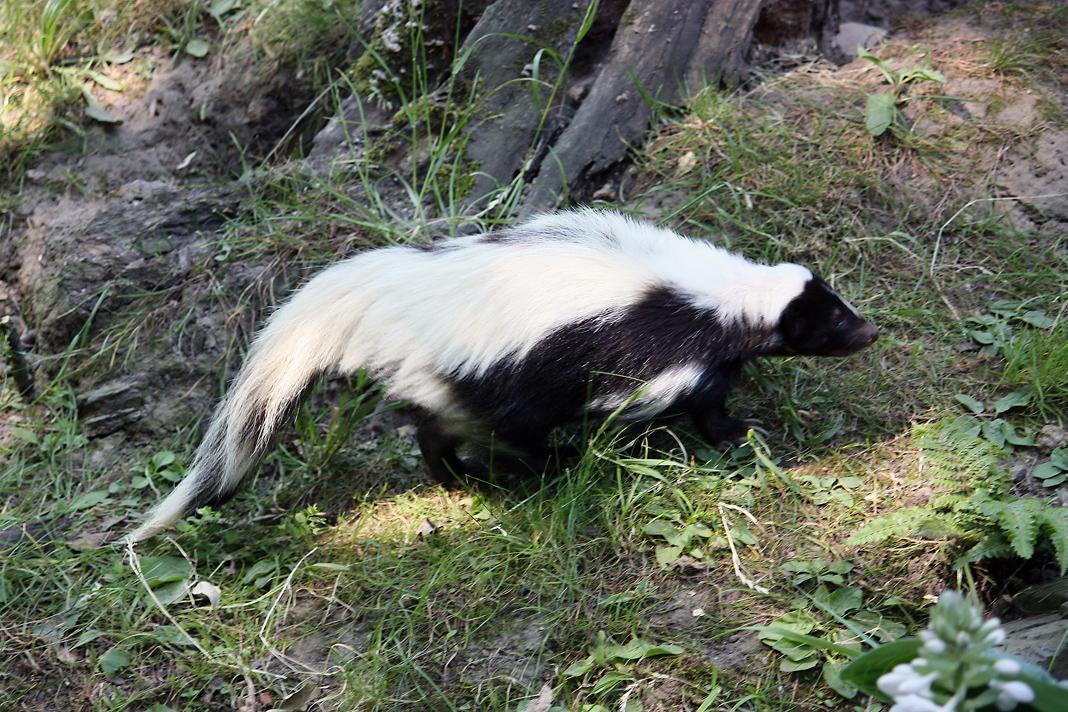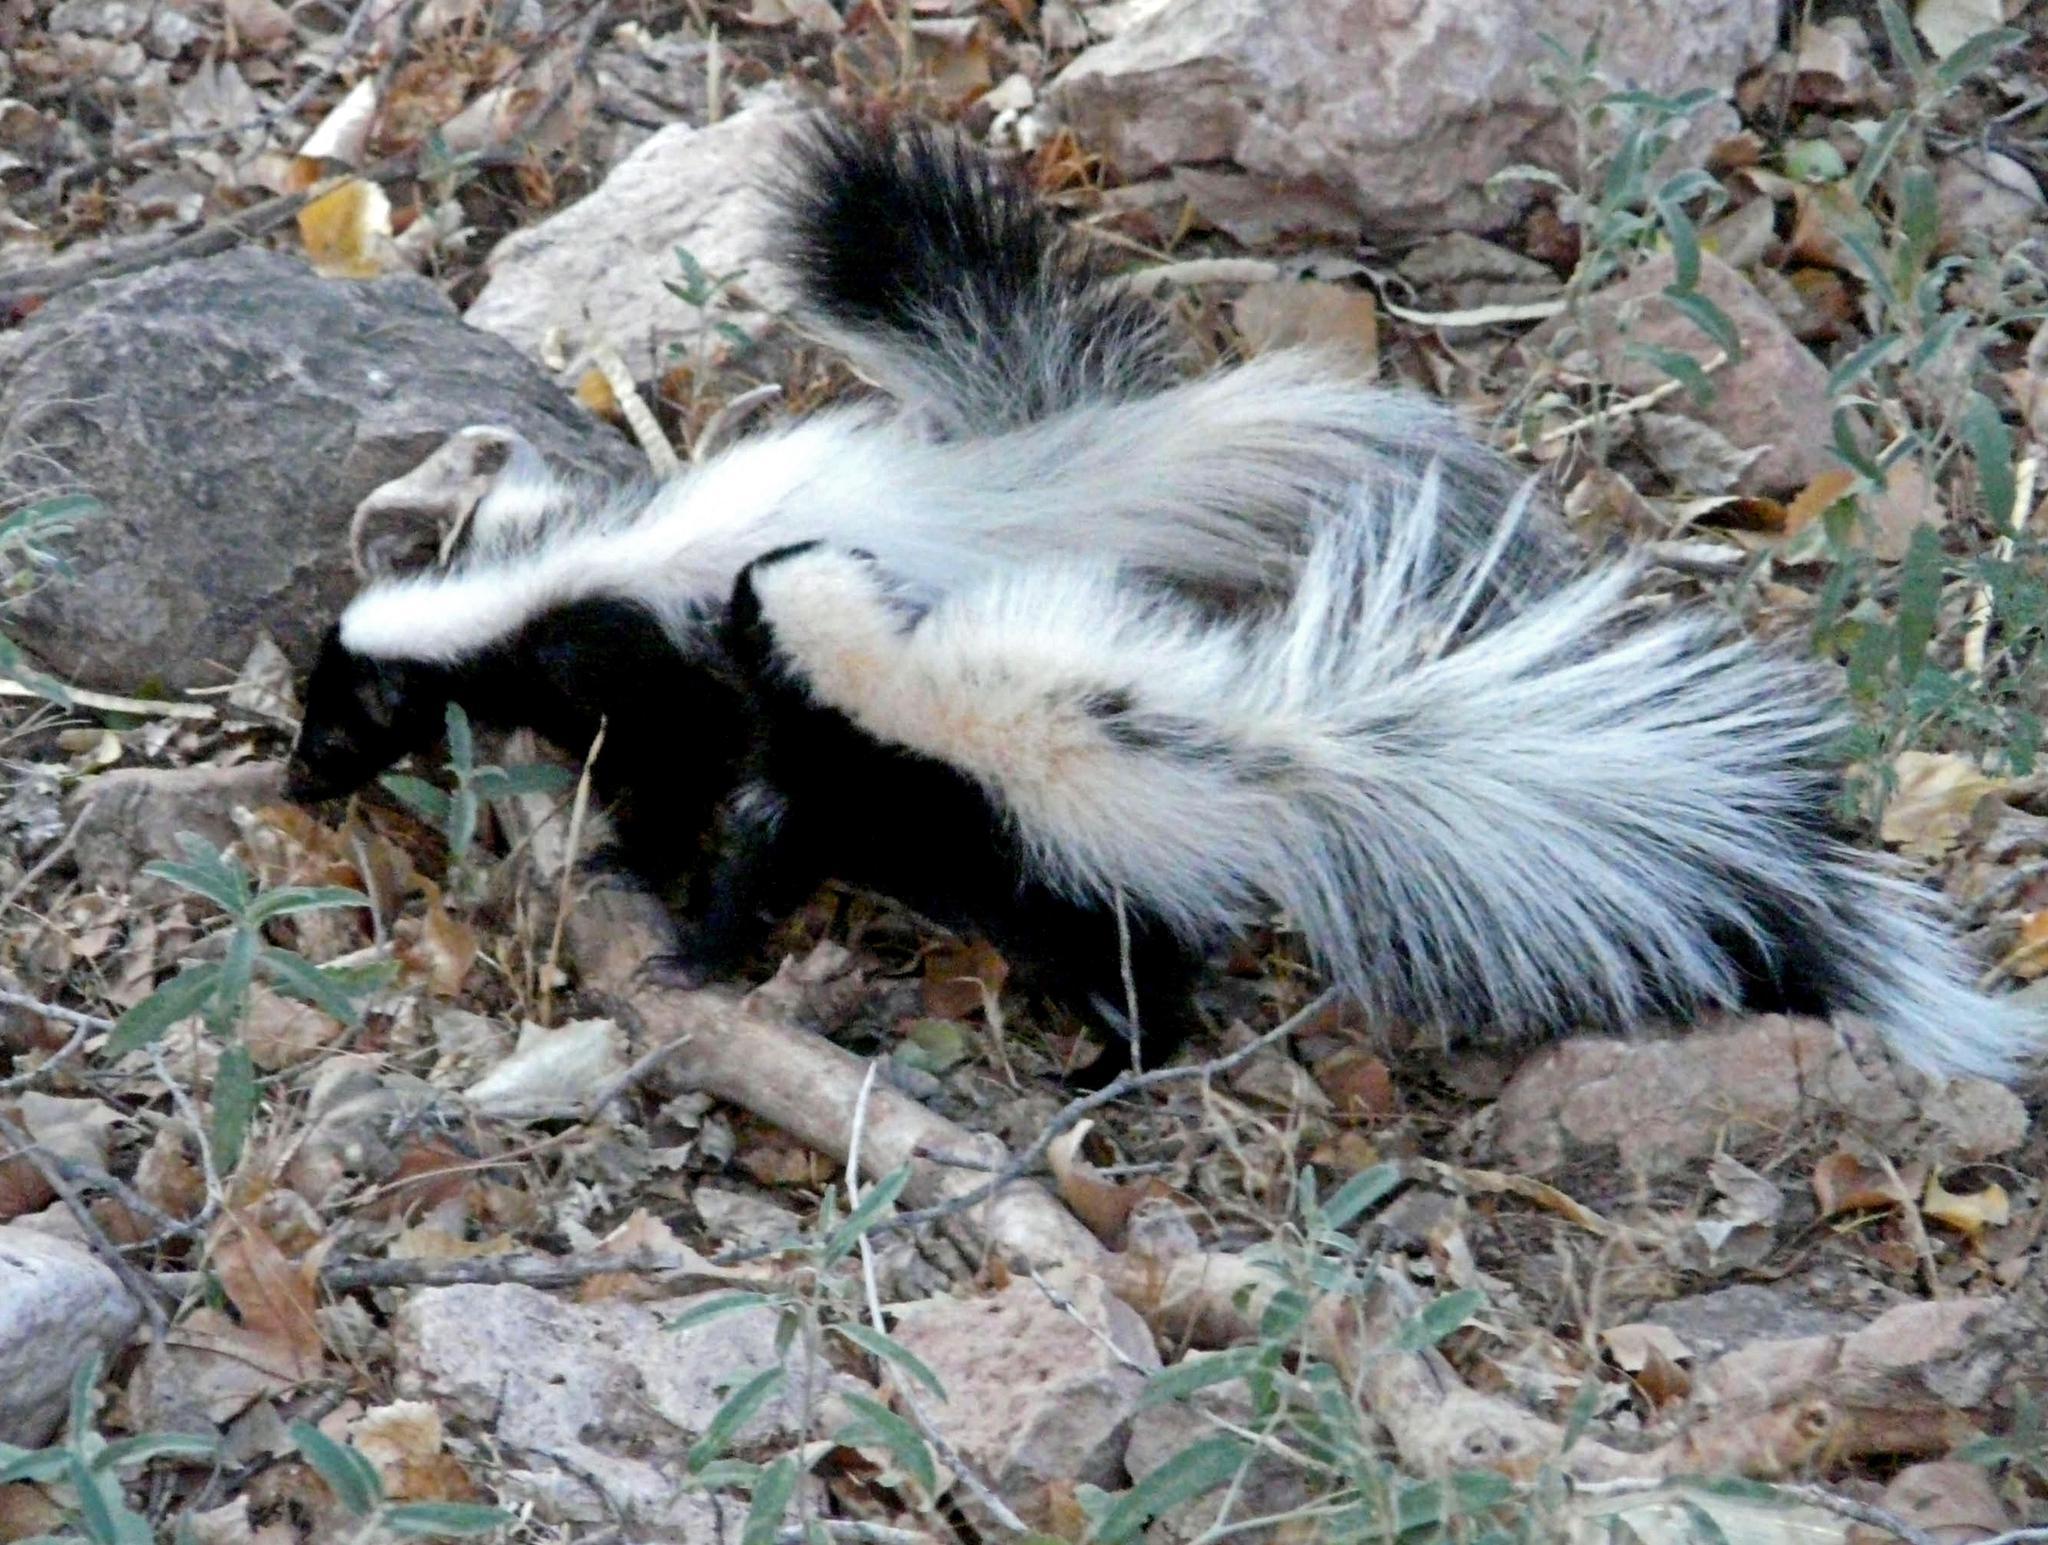The first image is the image on the left, the second image is the image on the right. For the images shown, is this caption "One image contains a spotted skunk with its face down and its tail somewhat curled, and the other image contains one skunk with bold white stripe, which is standing on all fours." true? Answer yes or no. No. 